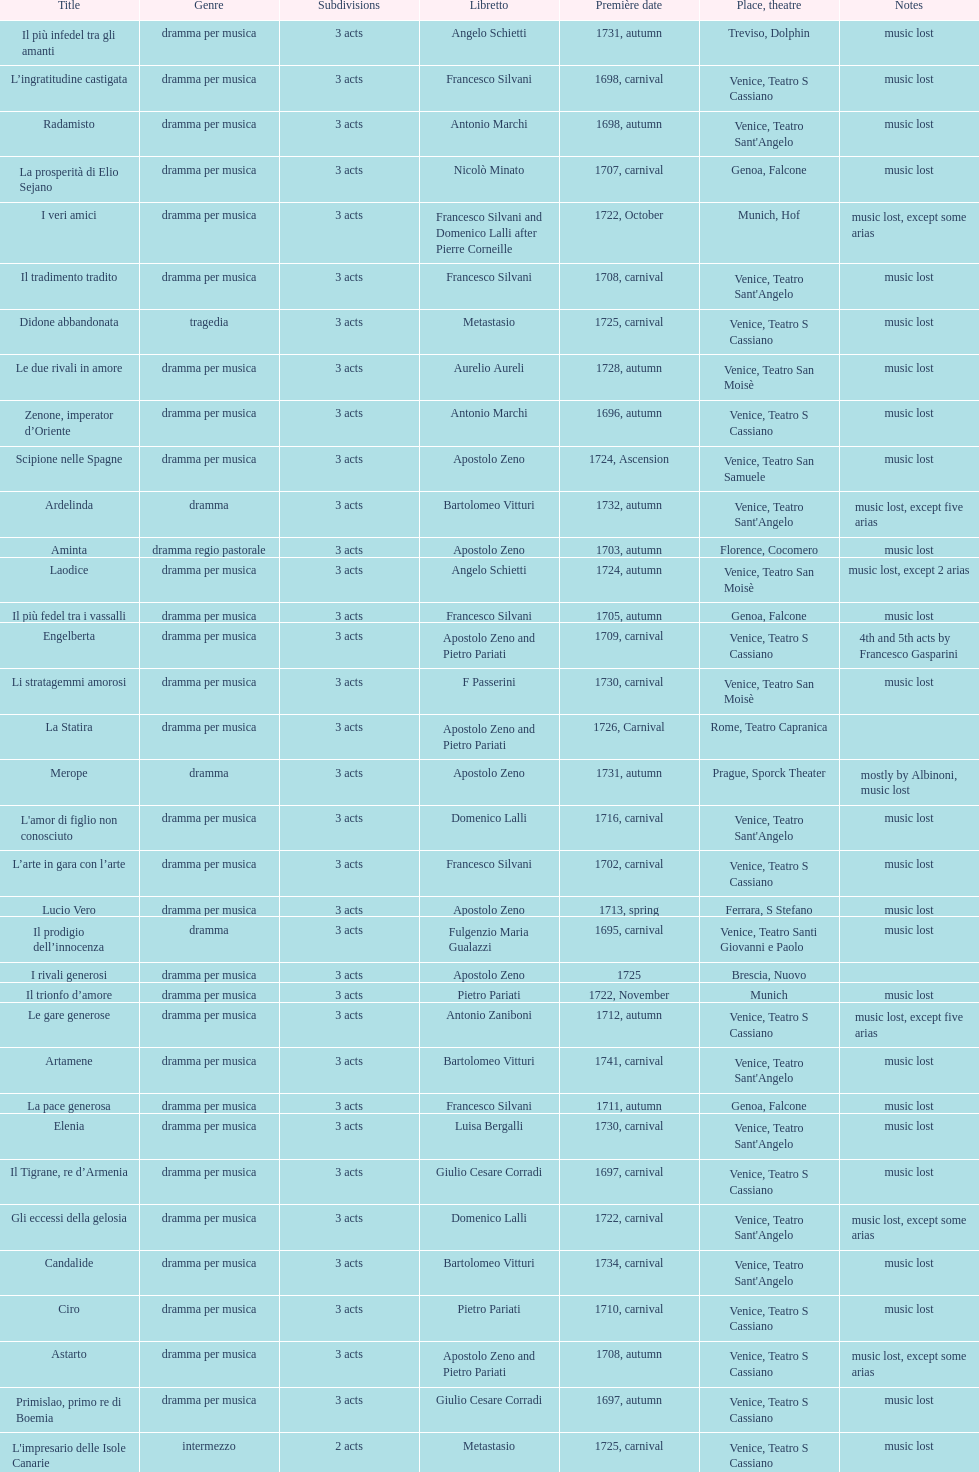Which was released earlier, artamene or merope? Merope. 